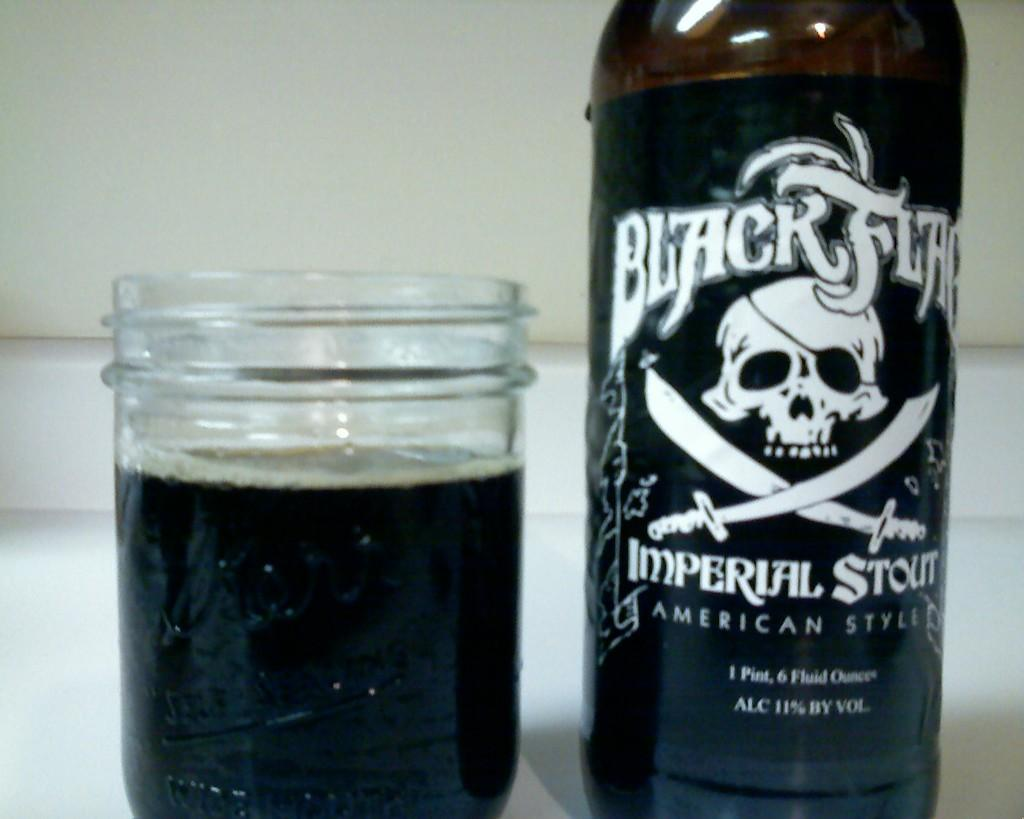Provide a one-sentence caption for the provided image. A bottle of black flag sits next to a jar filled with the contents. 